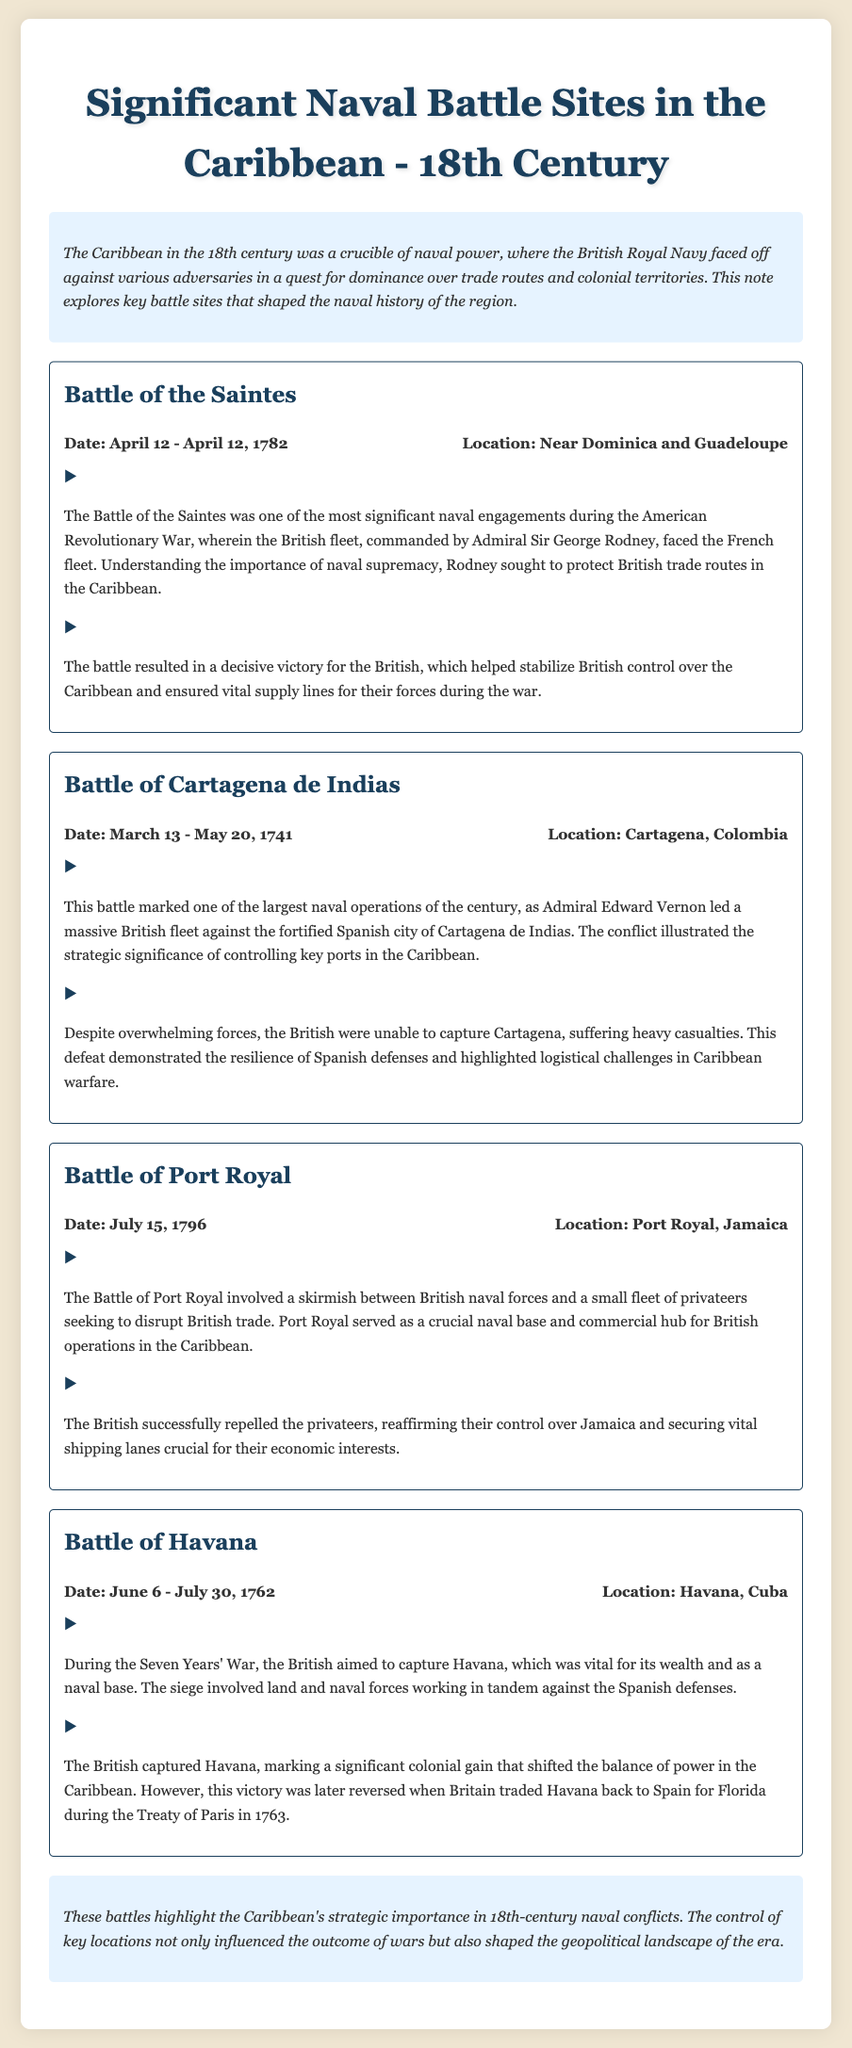what was the date of the Battle of the Saintes? The date of the Battle of the Saintes is mentioned as April 12 - April 12, 1782.
Answer: April 12 - April 12, 1782 who commanded the British fleet at the Battle of Cartagena de Indias? The document states that Admiral Edward Vernon led the British fleet during the Battle of Cartagena de Indias.
Answer: Admiral Edward Vernon what was the outcome of the Battle of Port Royal? The outcome detailed in the document indicates that the British successfully repelled the privateers at the Battle of Port Royal.
Answer: Successfully repelled the privateers what was the significance of capturing Havana during the Seven Years' War? The document explains that capturing Havana marked a significant colonial gain that shifted the balance of power in the Caribbean.
Answer: Shifted the balance of power how many days did the Battle of Cartagena de Indias last? The document states that the Battle of Cartagena de Indias lasted from March 13 to May 20, 1741, totaling 68 days.
Answer: 68 days what strategic location did the British aim to control during the Battle of Havana? The document specifies that the British aimed to capture Havana, which was vital for its wealth and as a naval base.
Answer: Havana what was a key reason for Admiral Sir George Rodney's actions in the Battle of the Saintes? The document notes that Rodney sought to protect British trade routes in the Caribbean, understanding the importance of naval supremacy.
Answer: Protect British trade routes which empire did Admiral Edward Vernon face at Cartagena de Indias? The document clearly states that Admiral Vernon faced the fortified Spanish city of Cartagena de Indias.
Answer: Spanish 